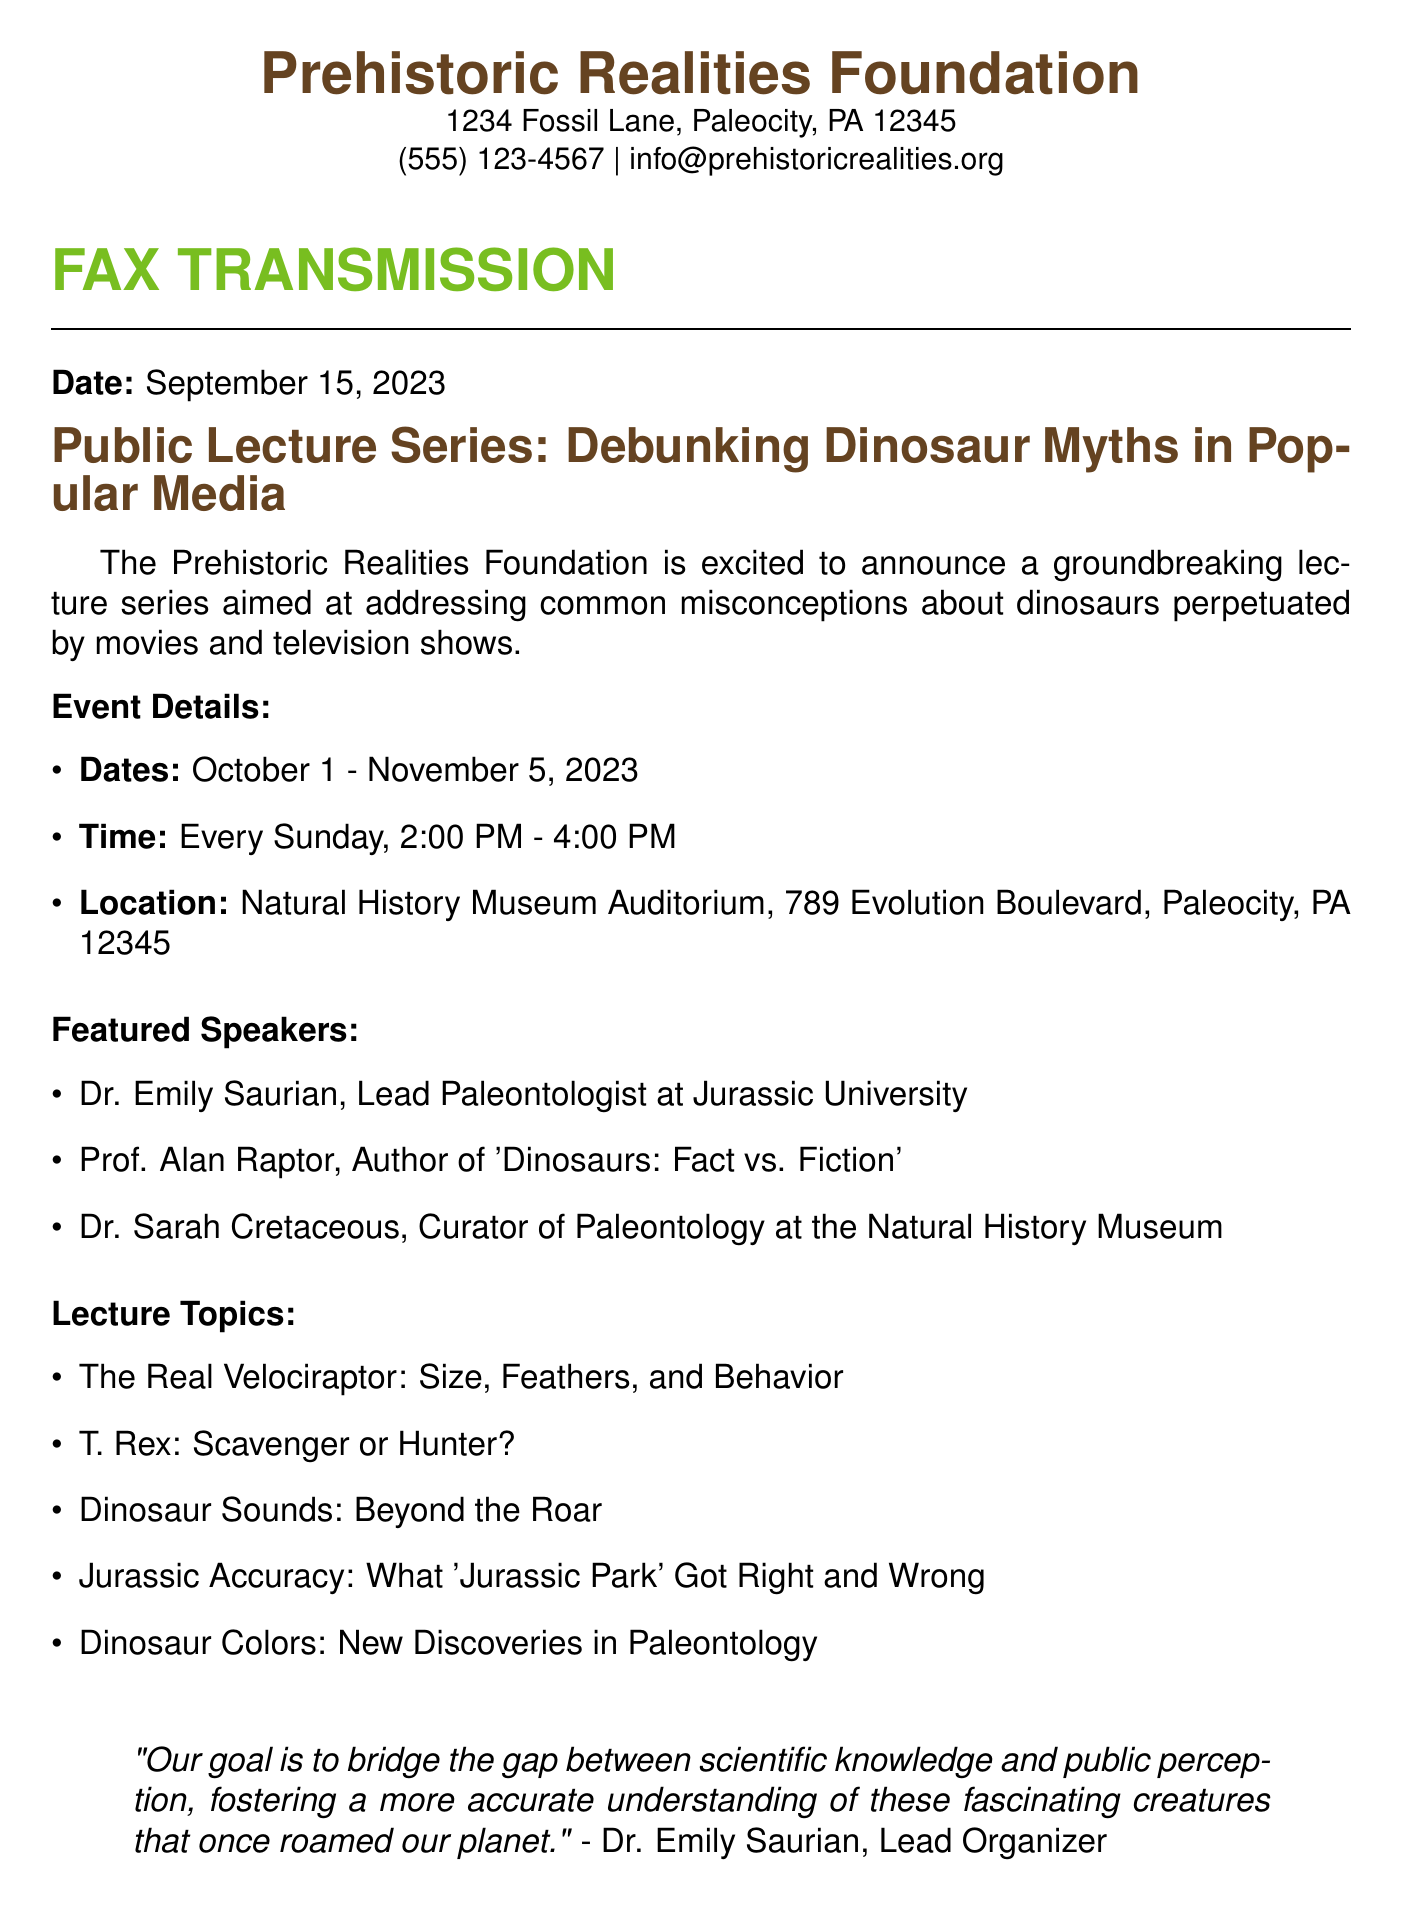What is the name of the foundation organizing the lecture series? The document states that the organizing foundation is the Prehistoric Realities Foundation.
Answer: Prehistoric Realities Foundation What are the dates of the lecture series? The document specifies the lecture series will take place from October 1 to November 5, 2023.
Answer: October 1 - November 5, 2023 Who is the lead paleontologist featured in the lecture series? According to the document, Dr. Emily Saurian is the Lead Paleontologist at Jurassic University.
Answer: Dr. Emily Saurian What is one of the topics covered in the lecture series? The document lists several topics, one of which is "T. Rex: Scavenger or Hunter?"
Answer: T. Rex: Scavenger or Hunter? What time do the lectures take place? The document indicates that the lectures are scheduled for every Sunday from 2:00 PM to 4:00 PM.
Answer: 2:00 PM - 4:00 PM Who is the Public Relations Manager for the foundation? The document provides the name of the Public Relations Manager as John Fossil.
Answer: John Fossil How often will the lectures occur during the series? The document states that the lectures will happen every Sunday, which indicates a weekly occurrence.
Answer: Every Sunday What is the location of the lecture series? The document lists the location as the Natural History Museum Auditorium, 789 Evolution Boulevard, Paleocity, PA 12345.
Answer: Natural History Museum Auditorium, 789 Evolution Boulevard, Paleocity, PA 12345 